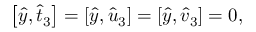<formula> <loc_0><loc_0><loc_500><loc_500>\begin{array} { r } { \left [ \hat { y } , \hat { t } _ { 3 } \right ] = \left [ \hat { y } , \hat { u } _ { 3 } \right ] = \left [ \hat { y } , \hat { v } _ { 3 } \right ] = 0 , } \end{array}</formula> 